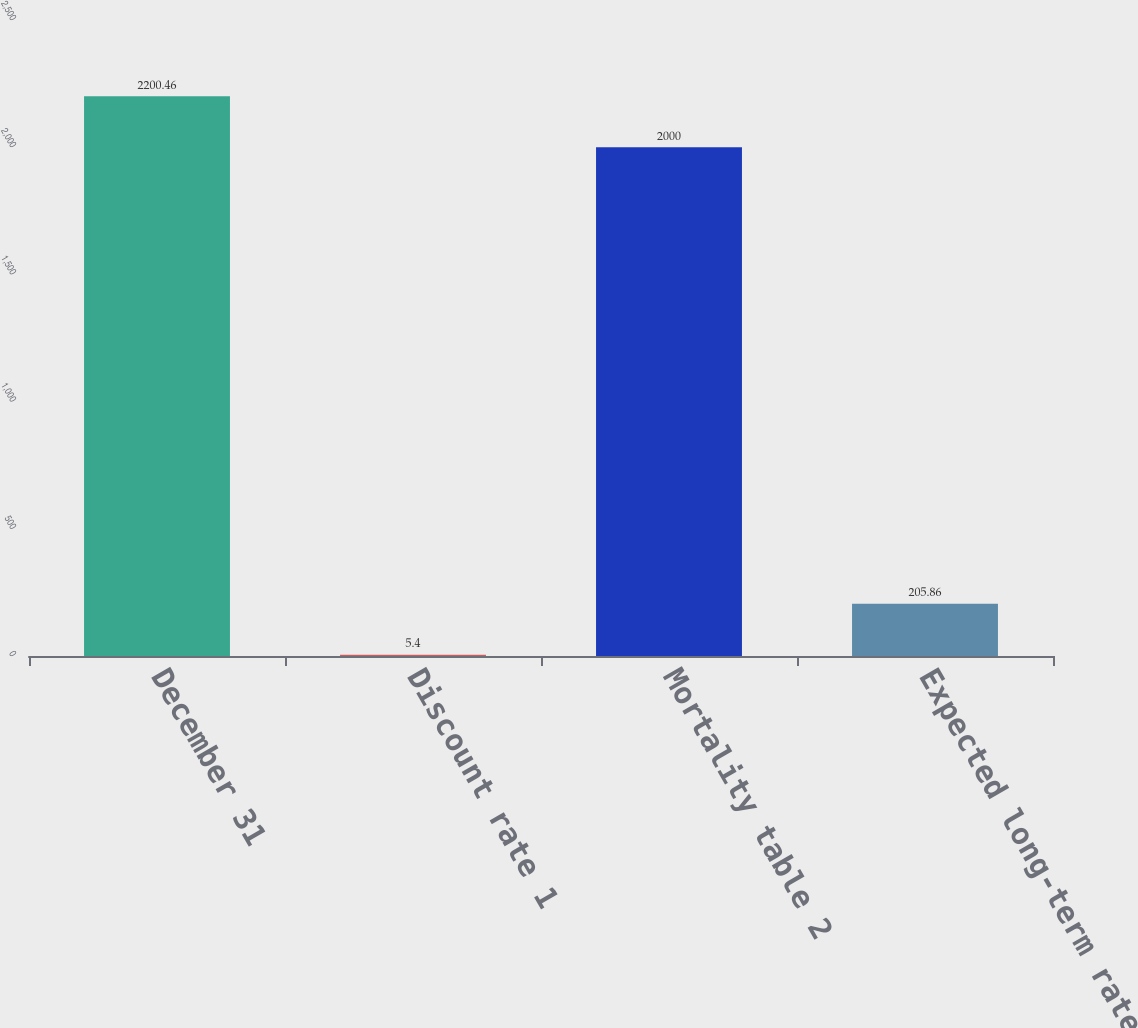Convert chart. <chart><loc_0><loc_0><loc_500><loc_500><bar_chart><fcel>December 31<fcel>Discount rate 1<fcel>Mortality table 2<fcel>Expected long-term rate of<nl><fcel>2200.46<fcel>5.4<fcel>2000<fcel>205.86<nl></chart> 